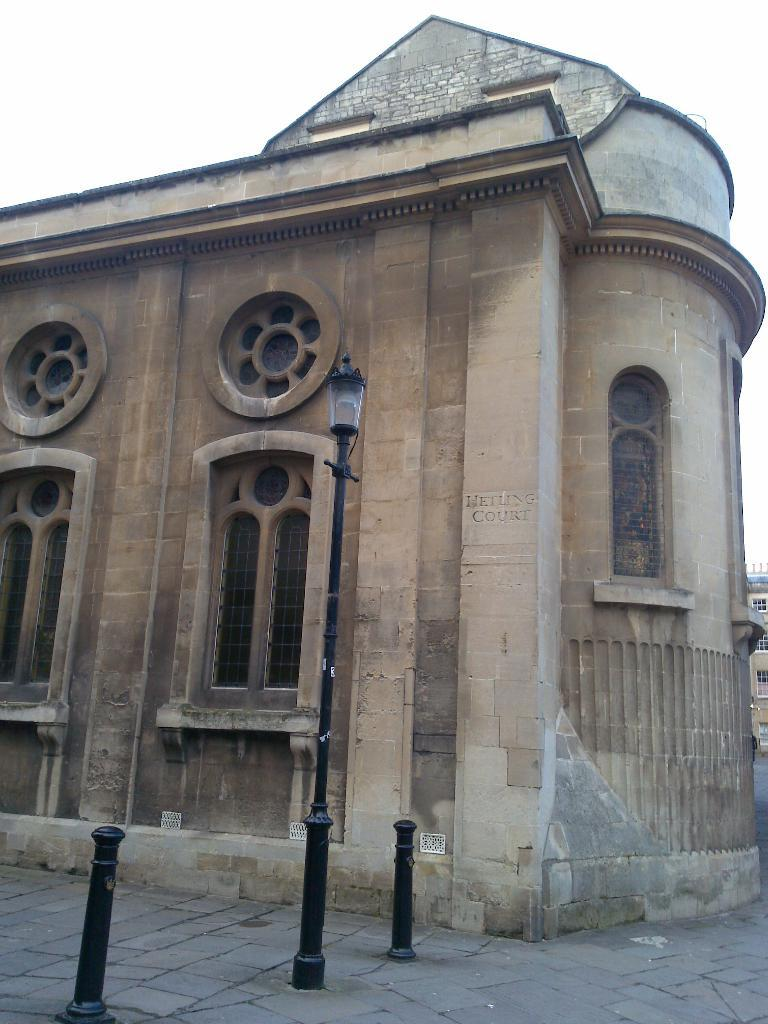What type of structure is featured in the image? There is a historical building in the image. Are there any specific features of the building that can be seen? Yes, the building has a window. What is located near the building? There is a path near the building. What can be seen in the background of the image? The sky is visible in the background of the image. What type of eggnog is being served by the grandmother in the image? There is no grandmother or eggnog present in the image; it features a historical building with a window and a path nearby. 